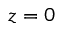<formula> <loc_0><loc_0><loc_500><loc_500>z = 0</formula> 